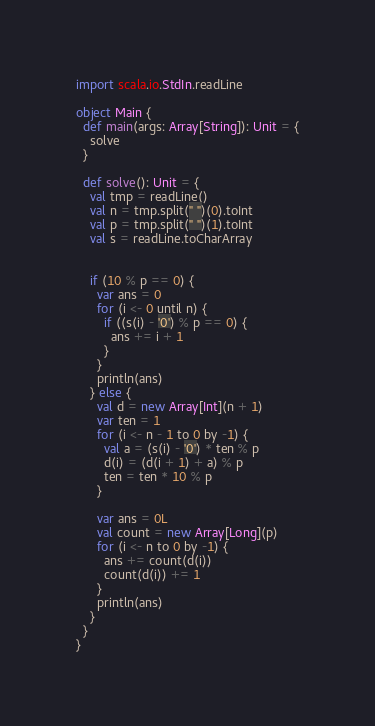<code> <loc_0><loc_0><loc_500><loc_500><_Scala_>import scala.io.StdIn.readLine

object Main {
  def main(args: Array[String]): Unit = {
    solve
  }

  def solve(): Unit = {
    val tmp = readLine()
    val n = tmp.split(" ")(0).toInt
    val p = tmp.split(" ")(1).toInt
    val s = readLine.toCharArray


    if (10 % p == 0) {
      var ans = 0
      for (i <- 0 until n) {
        if ((s(i) - '0') % p == 0) {
          ans += i + 1
        }
      }
      println(ans)
    } else {
      val d = new Array[Int](n + 1)
      var ten = 1
      for (i <- n - 1 to 0 by -1) {
        val a = (s(i) - '0') * ten % p
        d(i) = (d(i + 1) + a) % p
        ten = ten * 10 % p
      }

      var ans = 0L
      val count = new Array[Long](p)
      for (i <- n to 0 by -1) {
        ans += count(d(i))
        count(d(i)) += 1
      }
      println(ans)
    }
  }
}
</code> 